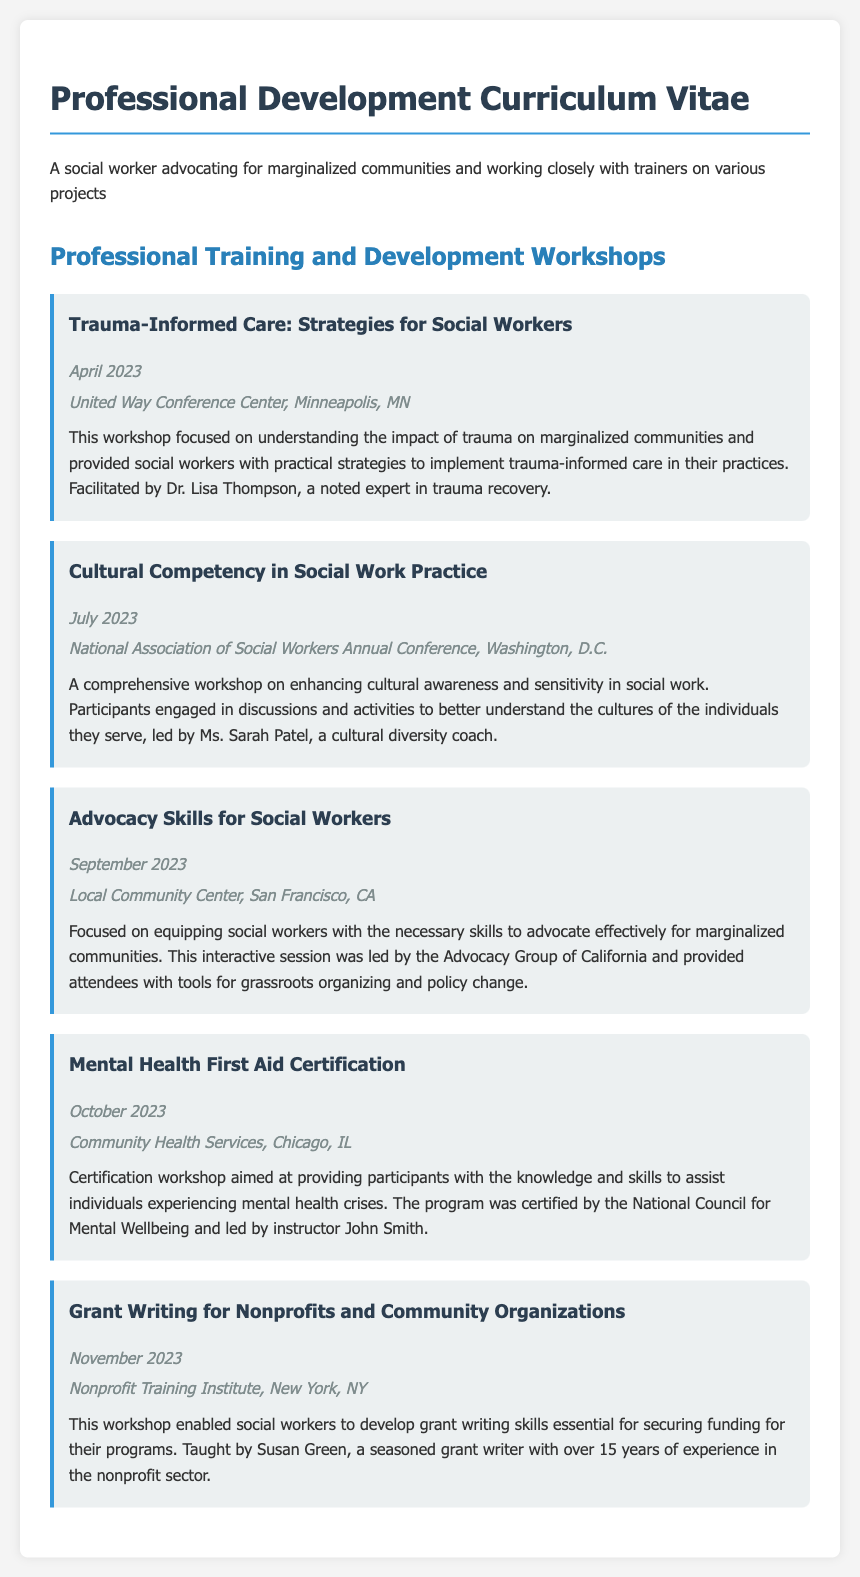what is the title of the first workshop? The title of the first workshop listed in the document is “Trauma-Informed Care: Strategies for Social Workers.”
Answer: Trauma-Informed Care: Strategies for Social Workers who facilitated the workshop on cultural competency? The workshop on cultural competency was facilitated by Ms. Sarah Patel, a cultural diversity coach.
Answer: Ms. Sarah Patel what month was the mental health first aid certification conducted? The mental health first aid certification workshop took place in October 2023.
Answer: October how many workshops were conducted in total? There are a total of five workshops listed in the document.
Answer: 5 what is the primary focus of the advocacy skills workshop? The advocacy skills workshop focused on equipping social workers with the necessary skills to advocate effectively for marginalized communities.
Answer: Advocating for marginalized communities which workshop is associated with grant writing skills? The workshop titled “Grant Writing for Nonprofits and Community Organizations” is associated with grant writing skills.
Answer: Grant Writing for Nonprofits and Community Organizations where was the trauma-informed care workshop held? The trauma-informed care workshop was held at the United Way Conference Center, Minneapolis, MN.
Answer: United Way Conference Center, Minneapolis, MN 